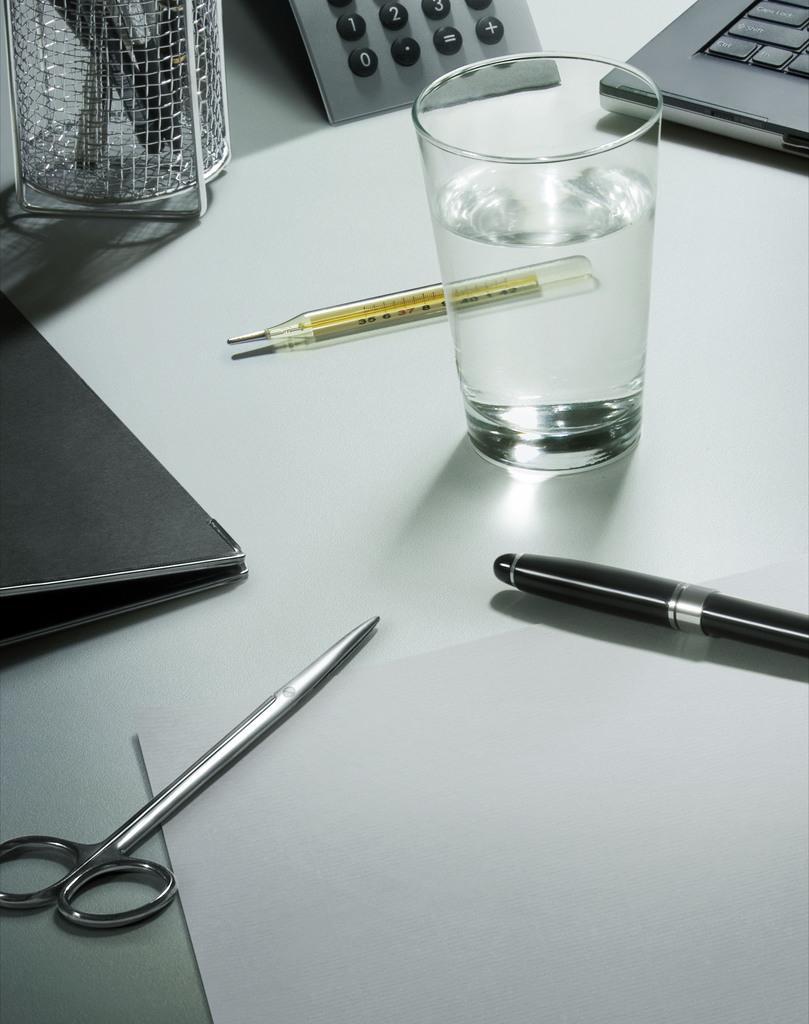Please provide a concise description of this image. In this image, I can see scissors, mercury thermometer, pen stand with pens, a calculator, pen, paper, a glass with water and few other objects on a white platform. 